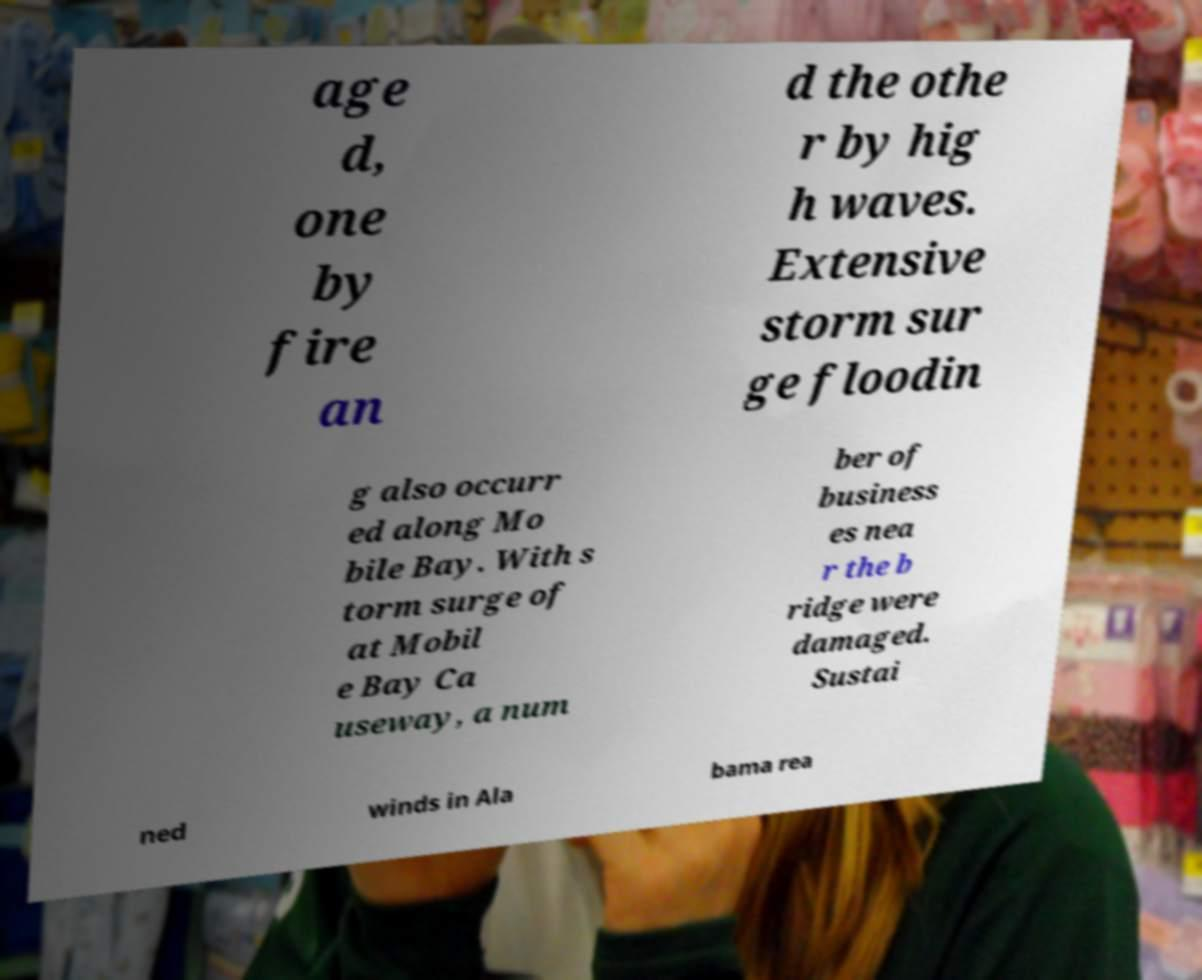There's text embedded in this image that I need extracted. Can you transcribe it verbatim? age d, one by fire an d the othe r by hig h waves. Extensive storm sur ge floodin g also occurr ed along Mo bile Bay. With s torm surge of at Mobil e Bay Ca useway, a num ber of business es nea r the b ridge were damaged. Sustai ned winds in Ala bama rea 